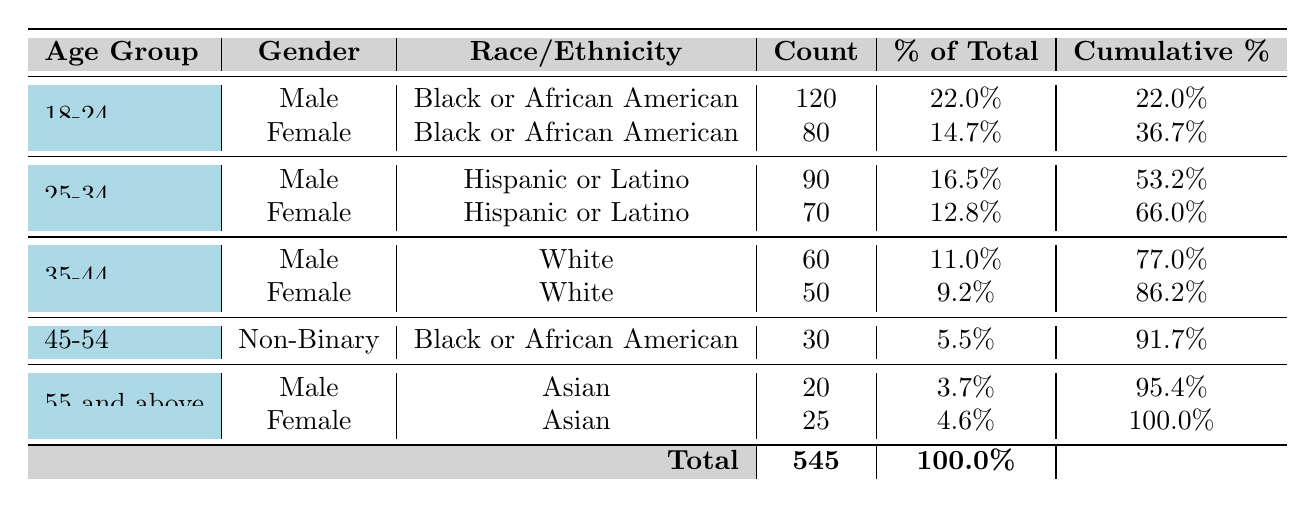What is the total number of individuals served by the organization in 2023? By adding the counts from all rows: 120 + 80 + 90 + 70 + 60 + 50 + 30 + 20 + 25 = 545. Therefore, the total number of individuals served is 545.
Answer: 545 How many females were served in the age group 25-34? From the table, the count for females in the age group 25-34 is 70.
Answer: 70 What percentage of the total individuals served were Black or African American? The total count for Black or African American individuals is 120 (male, age 18-24) + 80 (female, age 18-24) + 30 (non-binary, age 45-54) = 230. To find the percentage: (230/545) * 100 = 42.24%.
Answer: 42.24% Is the number of Hispanic or Latino males served greater than the number of Asian females served? The count of Hispanic or Latino males is 90, while the count of Asian females is 25. Since 90 is greater than 25, the answer is yes.
Answer: Yes What is the cumulative percentage of individuals served for the age group 35-44? The cumulative percentages for the age group 35-44 are calculated as follows: up to this group, we sum previous percentages: 22% (18-24 male) + 14.7% (18-24 female) + 16.5% (25-34 male) + 12.8% (25-34 female) + 11% (35-44 male) + 9.2% (35-44 female) = 86.2%. Hence, the cumulative percentage for this age group is 86.2%.
Answer: 86.2% What is the difference in count between males and females served in the 18-24 age group? The count for males in the 18-24 age group is 120 and for females is 80. The difference is 120 - 80 = 40.
Answer: 40 Which age group had the least number of individuals served? By reviewing the counts: 18-24 has 200, 25-34 has 160, 35-44 has 110, 45-54 has 30, 55 and above has 45. The age group 45-54 has the least number of individuals served at 30.
Answer: 45-54 What percent of the total count does the gender Non-Binary represent? There is 1 Non-Binary individual counted (30 in age group 45-54). To find the percentage: (30/545) * 100 = 5.5%.
Answer: 5.5% Did more individuals in the 55 and above age group identify as female than as male? In the 55 and above age group, males accounted for 20 individuals and females for 25. Since 25 is greater than 20, the answer is yes.
Answer: Yes 